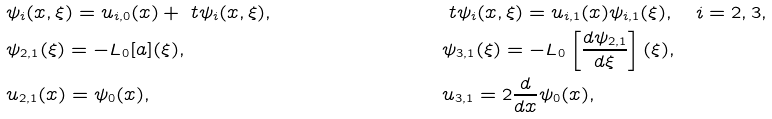Convert formula to latex. <formula><loc_0><loc_0><loc_500><loc_500>& \psi _ { i } ( x , \xi ) = u _ { i , 0 } ( x ) + \ t \psi _ { i } ( x , \xi ) , \quad & & \ t \psi _ { i } ( x , \xi ) = u _ { i , 1 } ( x ) \psi _ { i , 1 } ( \xi ) , \quad i = 2 , 3 , \\ & \psi _ { 2 , 1 } ( \xi ) = - { L } _ { 0 } [ a ] ( \xi ) , \quad & & \psi _ { 3 , 1 } ( \xi ) = - { L } _ { 0 } \left [ \frac { d \psi _ { 2 , 1 } } { d \xi } \right ] ( \xi ) , \\ & u _ { 2 , 1 } ( x ) = \psi _ { 0 } ( x ) , \quad & & u _ { 3 , 1 } = 2 \frac { d } { d x } \psi _ { 0 } ( x ) ,</formula> 